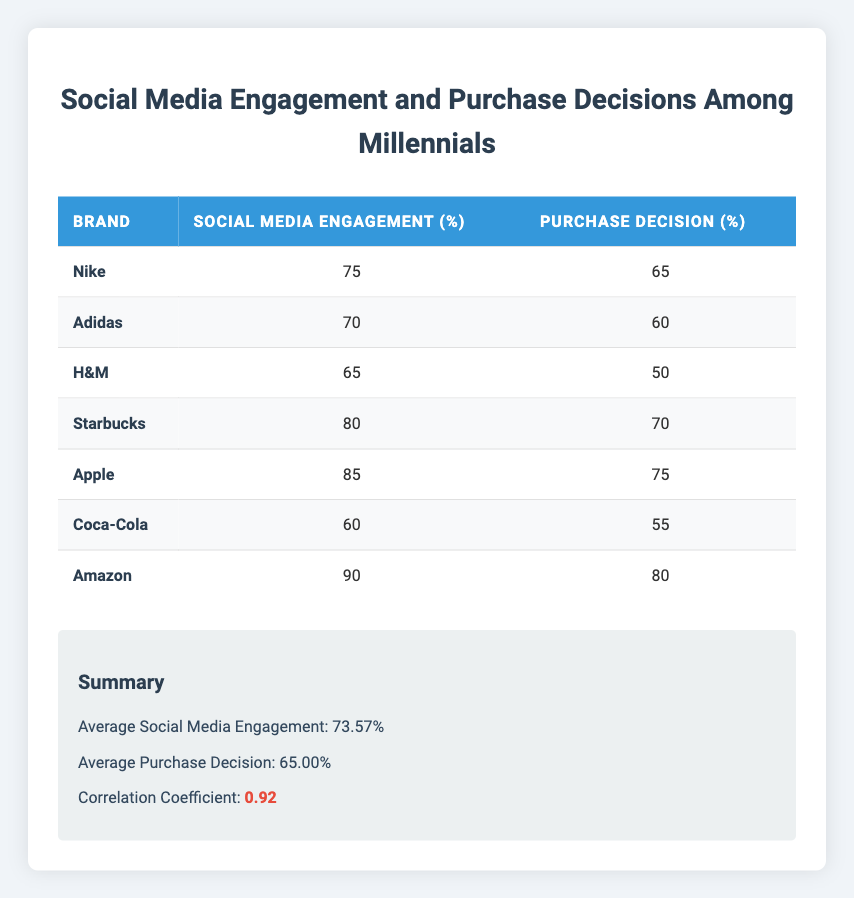What is the social media engagement percentage for Apple? The table shows that Apple's social media engagement percentage is listed directly under the “Social Media Engagement (%)” column next to the brand name "Apple," which states 85%.
Answer: 85 Which brand has the highest purchase decision percentage? By examining the "Purchase Decision (%)” column, it can be seen that Amazon has the highest percentage at 80%.
Answer: Amazon What is the average purchase decision percentage across all brands? The table summarizes that the average purchase decision percentage is listed as 65.00%, which can be found in the summary section.
Answer: 65.00 Is the correlation coefficient between social media engagement and purchase decisions positive? The table indicates the correlation coefficient as 0.92, which is greater than zero, hence confirming a positive correlation.
Answer: Yes How much higher is the social media engagement of Nike compared to H&M? Nike’s social media engagement is 75% while H&M’s is 65%. The difference is calculated as 75% - 65% = 10%.
Answer: 10% Which brand has the lowest social media engagement? The "Social Media Engagement (%)" column indicates that Coca-Cola has the lowest social media engagement at 60%.
Answer: Coca-Cola If Starbucks and Nike were combined, what would be their total social media engagement? For Starbucks, the engagement is 80% and for Nike, it is 75%. Adding these together gives 80% + 75% = 155%.
Answer: 155% What is the average social media engagement for brands that have a purchase decision percentage above 70%? The brands with purchase decision percentages above 70% are Apple (85%, 75%) and Amazon (90%, 80%). Their social media engagement is (85 + 90) / 2 = 87.5%.
Answer: 87.5% Is the purchase decision for Adidas greater than that of Coca-Cola? The table shows Adidas has a purchase decision percentage of 60% and Coca-Cola has 55%, indicating that 60% is indeed greater than 55%.
Answer: Yes 